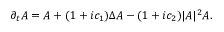Convert formula to latex. <formula><loc_0><loc_0><loc_500><loc_500>\partial _ { t } A = A + ( 1 + i c _ { 1 } ) \Delta A - ( 1 + i c _ { 2 } ) | A | ^ { 2 } A .</formula> 